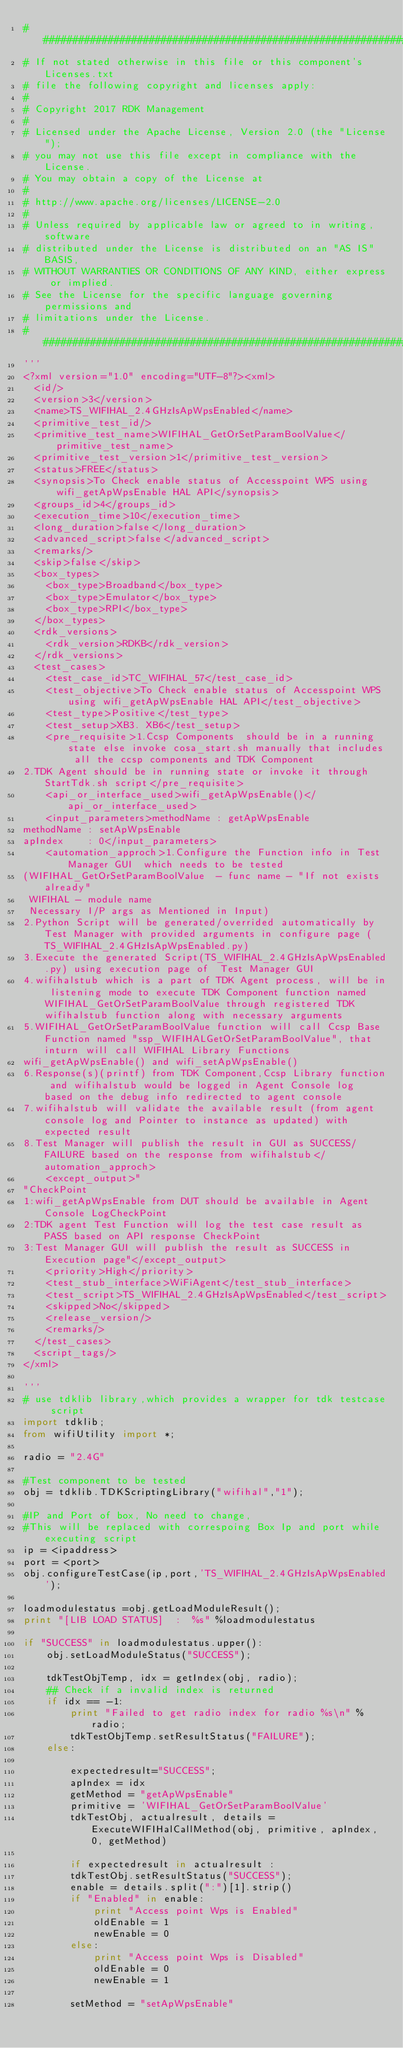Convert code to text. <code><loc_0><loc_0><loc_500><loc_500><_Python_>##########################################################################
# If not stated otherwise in this file or this component's Licenses.txt
# file the following copyright and licenses apply:
#
# Copyright 2017 RDK Management
#
# Licensed under the Apache License, Version 2.0 (the "License");
# you may not use this file except in compliance with the License.
# You may obtain a copy of the License at
#
# http://www.apache.org/licenses/LICENSE-2.0
#
# Unless required by applicable law or agreed to in writing, software
# distributed under the License is distributed on an "AS IS" BASIS,
# WITHOUT WARRANTIES OR CONDITIONS OF ANY KIND, either express or implied.
# See the License for the specific language governing permissions and
# limitations under the License.
##########################################################################
'''
<?xml version="1.0" encoding="UTF-8"?><xml>
  <id/>
  <version>3</version>
  <name>TS_WIFIHAL_2.4GHzIsApWpsEnabled</name>
  <primitive_test_id/>
  <primitive_test_name>WIFIHAL_GetOrSetParamBoolValue</primitive_test_name>
  <primitive_test_version>1</primitive_test_version>
  <status>FREE</status>
  <synopsis>To Check enable status of Accesspoint WPS using wifi_getApWpsEnable HAL API</synopsis>
  <groups_id>4</groups_id>
  <execution_time>10</execution_time>
  <long_duration>false</long_duration>
  <advanced_script>false</advanced_script>
  <remarks/>
  <skip>false</skip>
  <box_types>
    <box_type>Broadband</box_type>
    <box_type>Emulator</box_type>
    <box_type>RPI</box_type>
  </box_types>
  <rdk_versions>
    <rdk_version>RDKB</rdk_version>
  </rdk_versions>
  <test_cases>
    <test_case_id>TC_WIFIHAL_57</test_case_id>
    <test_objective>To Check enable status of Accesspoint WPS using wifi_getApWpsEnable HAL API</test_objective>
    <test_type>Positive</test_type>
    <test_setup>XB3. XB6</test_setup>
    <pre_requisite>1.Ccsp Components  should be in a running state else invoke cosa_start.sh manually that includes all the ccsp components and TDK Component
2.TDK Agent should be in running state or invoke it through StartTdk.sh script</pre_requisite>
    <api_or_interface_used>wifi_getApWpsEnable()</api_or_interface_used>
    <input_parameters>methodName : getApWpsEnable
methodName : setApWpsEnable
apIndex    : 0</input_parameters>
    <automation_approch>1.Configure the Function info in Test Manager GUI  which needs to be tested  
(WIFIHAL_GetOrSetParamBoolValue  - func name - "If not exists already"
 WIFIHAL - module name
 Necessary I/P args as Mentioned in Input)
2.Python Script will be generated/overrided automatically by Test Manager with provided arguments in configure page (TS_WIFIHAL_2.4GHzIsApWpsEnabled.py)
3.Execute the generated Script(TS_WIFIHAL_2.4GHzIsApWpsEnabled.py) using execution page of  Test Manager GUI
4.wifihalstub which is a part of TDK Agent process, will be in listening mode to execute TDK Component function named WIFIHAL_GetOrSetParamBoolValue through registered TDK wifihalstub function along with necessary arguments
5.WIFIHAL_GetOrSetParamBoolValue function will call Ccsp Base Function named "ssp_WIFIHALGetOrSetParamBoolValue", that inturn will call WIFIHAL Library Functions 
wifi_getApWpsEnable() and wifi_setApWpsEnable()
6.Response(s)(printf) from TDK Component,Ccsp Library function and wifihalstub would be logged in Agent Console log based on the debug info redirected to agent console
7.wifihalstub will validate the available result (from agent console log and Pointer to instance as updated) with expected result
8.Test Manager will publish the result in GUI as SUCCESS/FAILURE based on the response from wifihalstub</automation_approch>
    <except_output>"
"CheckPoint 
1:wifi_getApWpsEnable from DUT should be available in Agent Console LogCheckPoint 
2:TDK agent Test Function will log the test case result as PASS based on API response CheckPoint 
3:Test Manager GUI will publish the result as SUCCESS in Execution page"</except_output>
    <priority>High</priority>
    <test_stub_interface>WiFiAgent</test_stub_interface>
    <test_script>TS_WIFIHAL_2.4GHzIsApWpsEnabled</test_script>
    <skipped>No</skipped>
    <release_version/>
    <remarks/>
  </test_cases>
  <script_tags/>
</xml>

'''
# use tdklib library,which provides a wrapper for tdk testcase script 
import tdklib; 
from wifiUtility import *;

radio = "2.4G"

#Test component to be tested
obj = tdklib.TDKScriptingLibrary("wifihal","1");

#IP and Port of box, No need to change,
#This will be replaced with correspoing Box Ip and port while executing script
ip = <ipaddress>
port = <port>
obj.configureTestCase(ip,port,'TS_WIFIHAL_2.4GHzIsApWpsEnabled');

loadmodulestatus =obj.getLoadModuleResult();
print "[LIB LOAD STATUS]  :  %s" %loadmodulestatus

if "SUCCESS" in loadmodulestatus.upper():
    obj.setLoadModuleStatus("SUCCESS");

    tdkTestObjTemp, idx = getIndex(obj, radio);
    ## Check if a invalid index is returned
    if idx == -1:
        print "Failed to get radio index for radio %s\n" %radio;
        tdkTestObjTemp.setResultStatus("FAILURE");
    else: 

	    expectedresult="SUCCESS";
	    apIndex = idx
	    getMethod = "getApWpsEnable"
	    primitive = 'WIFIHAL_GetOrSetParamBoolValue'
	    tdkTestObj, actualresult, details = ExecuteWIFIHalCallMethod(obj, primitive, apIndex, 0, getMethod)

	    if expectedresult in actualresult :
		tdkTestObj.setResultStatus("SUCCESS");
		enable = details.split(":")[1].strip()
		if "Enabled" in enable:
		    print "Access point Wps is Enabled"
		    oldEnable = 1
		    newEnable = 0
		else:
		    print "Access point Wps is Disabled"
		    oldEnable = 0
		    newEnable = 1

		setMethod = "setApWpsEnable"</code> 